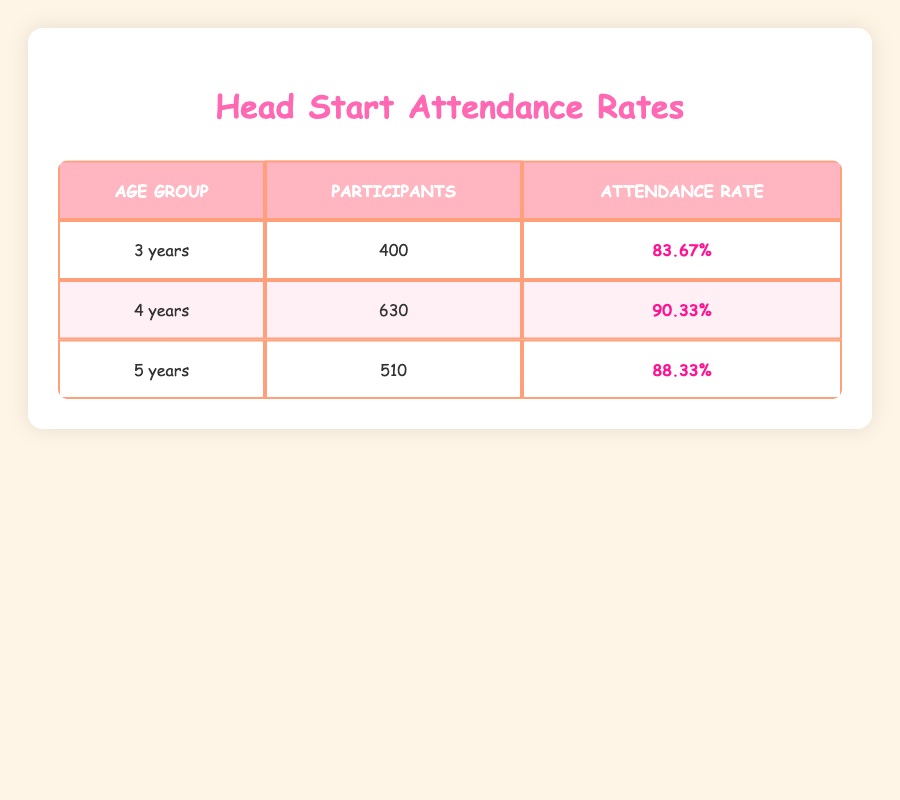What is the attendance rate for 4-year-old participants? The attendance rate for 4-year-olds can be found directly in the table under the "Attendance Rate" column for the "4 years" row. It states that the attendance rate is 90.33%.
Answer: 90.33% How many total participants are there in the 5-year age group? To find the total participants in the 5-year age group, we look at the "Participants" column for the "5 years" row in the table. It shows a total of 510 participants.
Answer: 510 Which age group has the highest attendance rate? The age groups' attendance rates are listed in the table: 83.67% for 3 years, 90.33% for 4 years, and 88.33% for 5 years. The highest rate among these is for the 4-year age group at 90.33%.
Answer: 4 years What is the average attendance rate across all age groups? The attendance rates for the three age groups are 83.67%, 90.33%, and 88.33%. To find the average, we sum these rates (83.67 + 90.33 + 88.33 = 262.33) and then divide by 3 (262.33 / 3 = 87.44). Therefore, the average attendance rate is 87.44%.
Answer: 87.44% Is the attendance rate for the 3-year age group above 80%? The attendance rate for the 3-year age group is 83.67%, which is greater than 80%. Thus, the answer is yes.
Answer: Yes Which age group has the lowest total number of participants? Comparing the total participants, we see that 3 years has 400, 4 years has 630, and 5 years has 510. The lowest total is for the 3-year age group with 400 participants.
Answer: 3 years How much higher is the average attendance rate of 4-year-olds compared to 5-year-olds? The attendance rate for 4-year-olds is 90.33% and for 5-year-olds is 88.33%. The difference is calculated as 90.33% - 88.33%, which equals 2%. Therefore, 4-year-olds have an attendance rate that is 2% higher compared to 5-year-olds.
Answer: 2% What percentage of participants are in the 3-year age group compared to the total participants of all age groups? The total participants across all age groups are 400 (3 years) + 630 (4 years) + 510 (5 years) = 1540. The percentage for the 3-year age group is (400 / 1540) * 100%, which gives approximately 25.97%.
Answer: 25.97% 